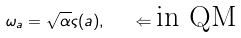<formula> <loc_0><loc_0><loc_500><loc_500>\omega _ { a } = \sqrt { \alpha } \varsigma ( a ) , \quad \Leftarrow \text {in QM}</formula> 